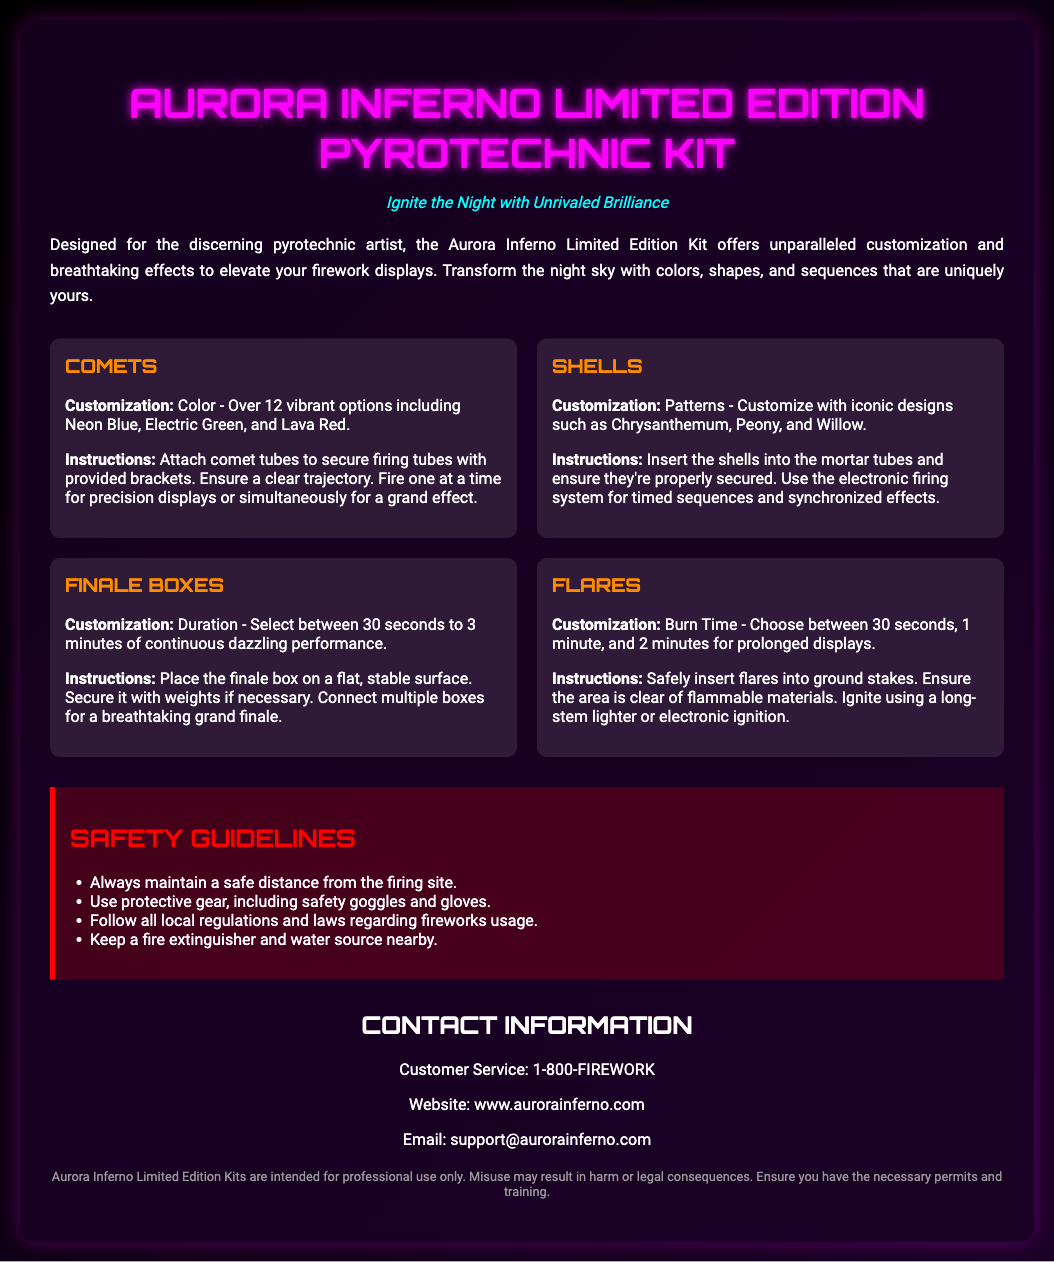What is the title of the kit? The title of the kit is prominently displayed at the top of the document.
Answer: Aurora Inferno Limited Edition Pyrotechnic Kit How many vibrant color options are available for comets? The document specifies the range of color options that users can choose from for comets.
Answer: Over 12 vibrant options What is the maximum duration for finale boxes? The document mentions the time range for finale boxes available in the kit, indicating the longest option.
Answer: 3 minutes What safety gear is recommended? The document lists protective gear that users should wear when using the fireworks.
Answer: Safety goggles and gloves What is the website for customer service? The document provides the official website for customers seeking more information.
Answer: www.aurorainferno.com What is required for inserting shells? The instructions section indicates what users need to ensure when inserting shells into mortar tubes.
Answer: Properly secured What should be kept nearby for emergencies? The safety guidelines mention essential items to have ready in case of emergency during fireworks usage.
Answer: Fire extinguisher and water source What unique designs are mentioned for shells? The customization section lists different iconic shapes available for shells.
Answer: Chrysanthemum, Peony, and Willow What type of document is this? The overall context and content indicate the kind of publication this is for its intended audience and purpose.
Answer: Product packaging 